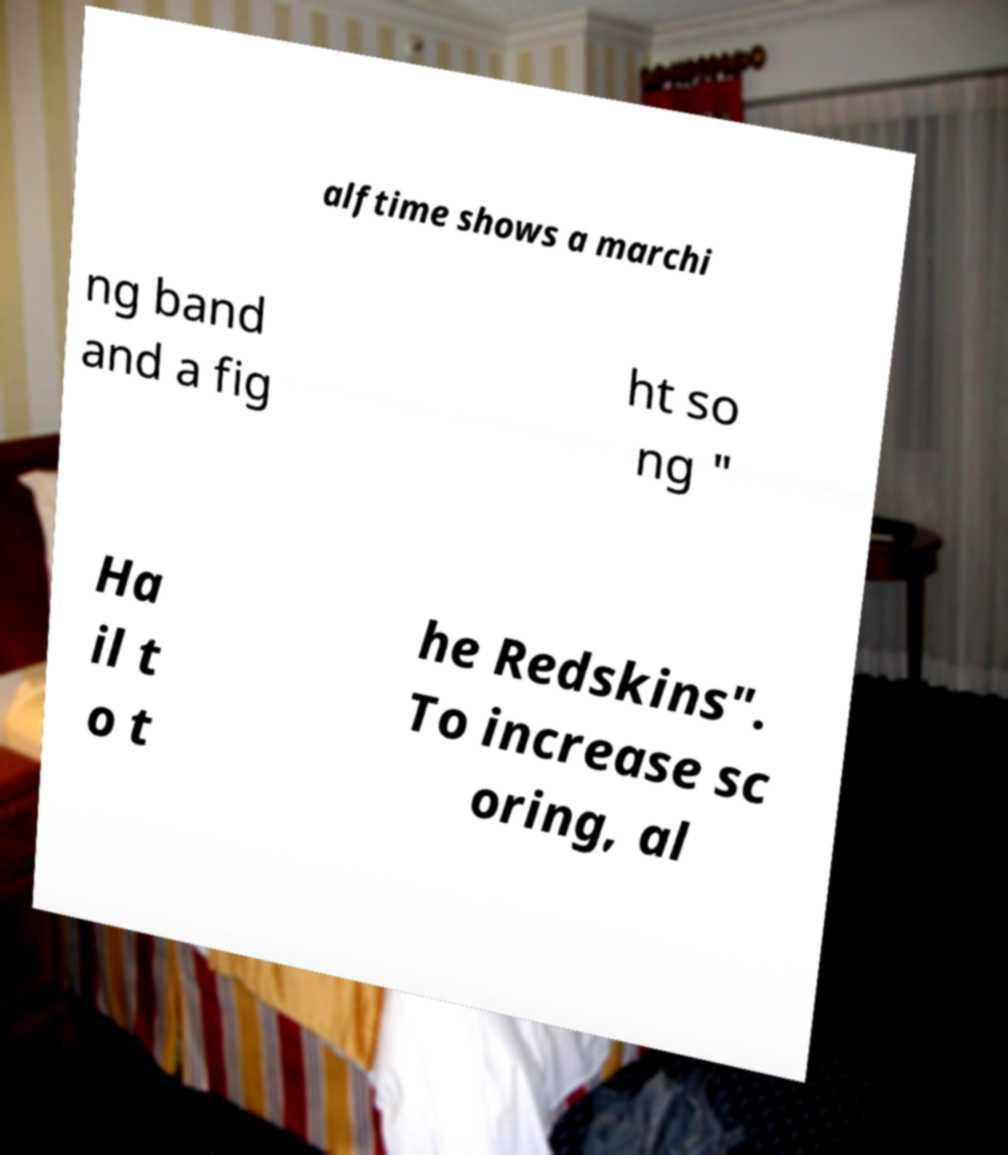There's text embedded in this image that I need extracted. Can you transcribe it verbatim? alftime shows a marchi ng band and a fig ht so ng " Ha il t o t he Redskins". To increase sc oring, al 